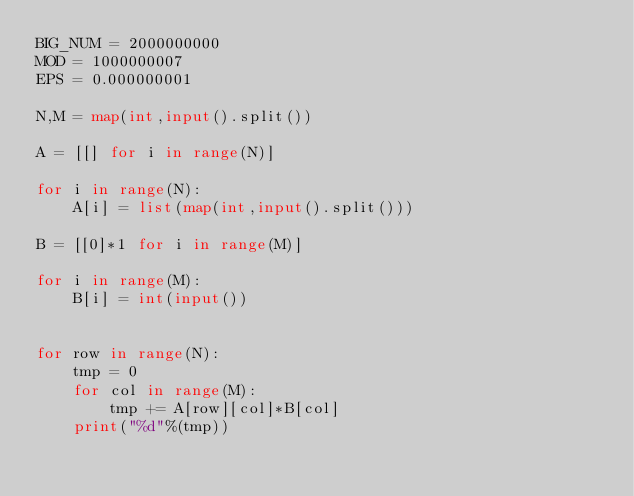<code> <loc_0><loc_0><loc_500><loc_500><_Python_>BIG_NUM = 2000000000
MOD = 1000000007
EPS = 0.000000001

N,M = map(int,input().split())

A = [[] for i in range(N)]

for i in range(N):
    A[i] = list(map(int,input().split()))

B = [[0]*1 for i in range(M)]

for i in range(M):
    B[i] = int(input())


for row in range(N):
    tmp = 0
    for col in range(M):
        tmp += A[row][col]*B[col]
    print("%d"%(tmp))

</code> 